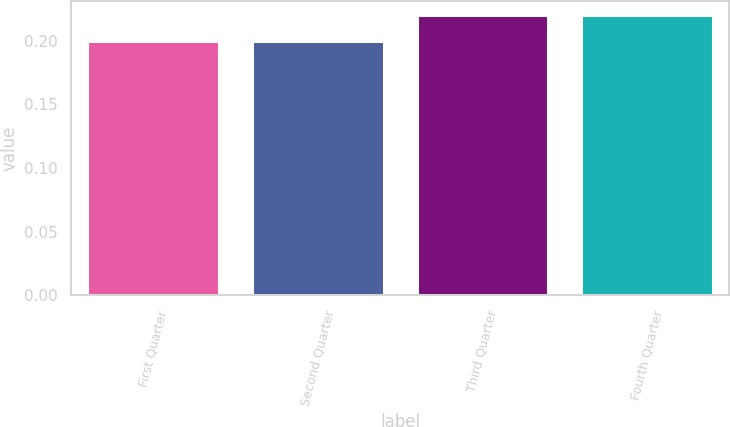Convert chart to OTSL. <chart><loc_0><loc_0><loc_500><loc_500><bar_chart><fcel>First Quarter<fcel>Second Quarter<fcel>Third Quarter<fcel>Fourth Quarter<nl><fcel>0.2<fcel>0.2<fcel>0.22<fcel>0.22<nl></chart> 